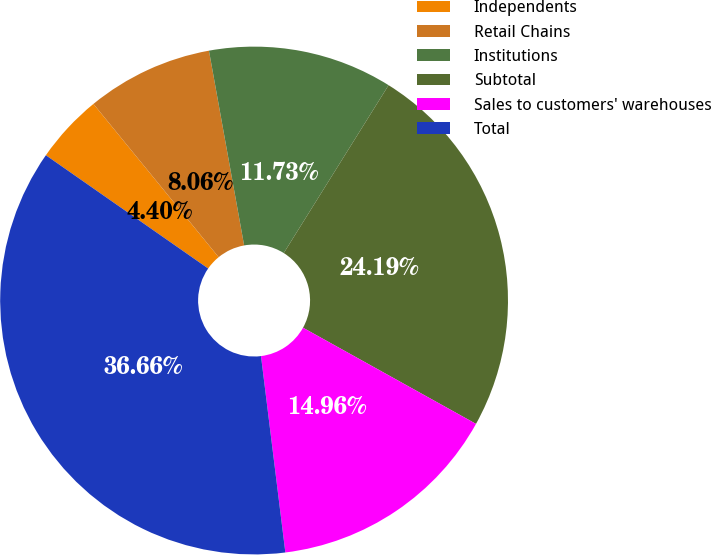Convert chart to OTSL. <chart><loc_0><loc_0><loc_500><loc_500><pie_chart><fcel>Independents<fcel>Retail Chains<fcel>Institutions<fcel>Subtotal<fcel>Sales to customers' warehouses<fcel>Total<nl><fcel>4.4%<fcel>8.06%<fcel>11.73%<fcel>24.19%<fcel>14.96%<fcel>36.66%<nl></chart> 